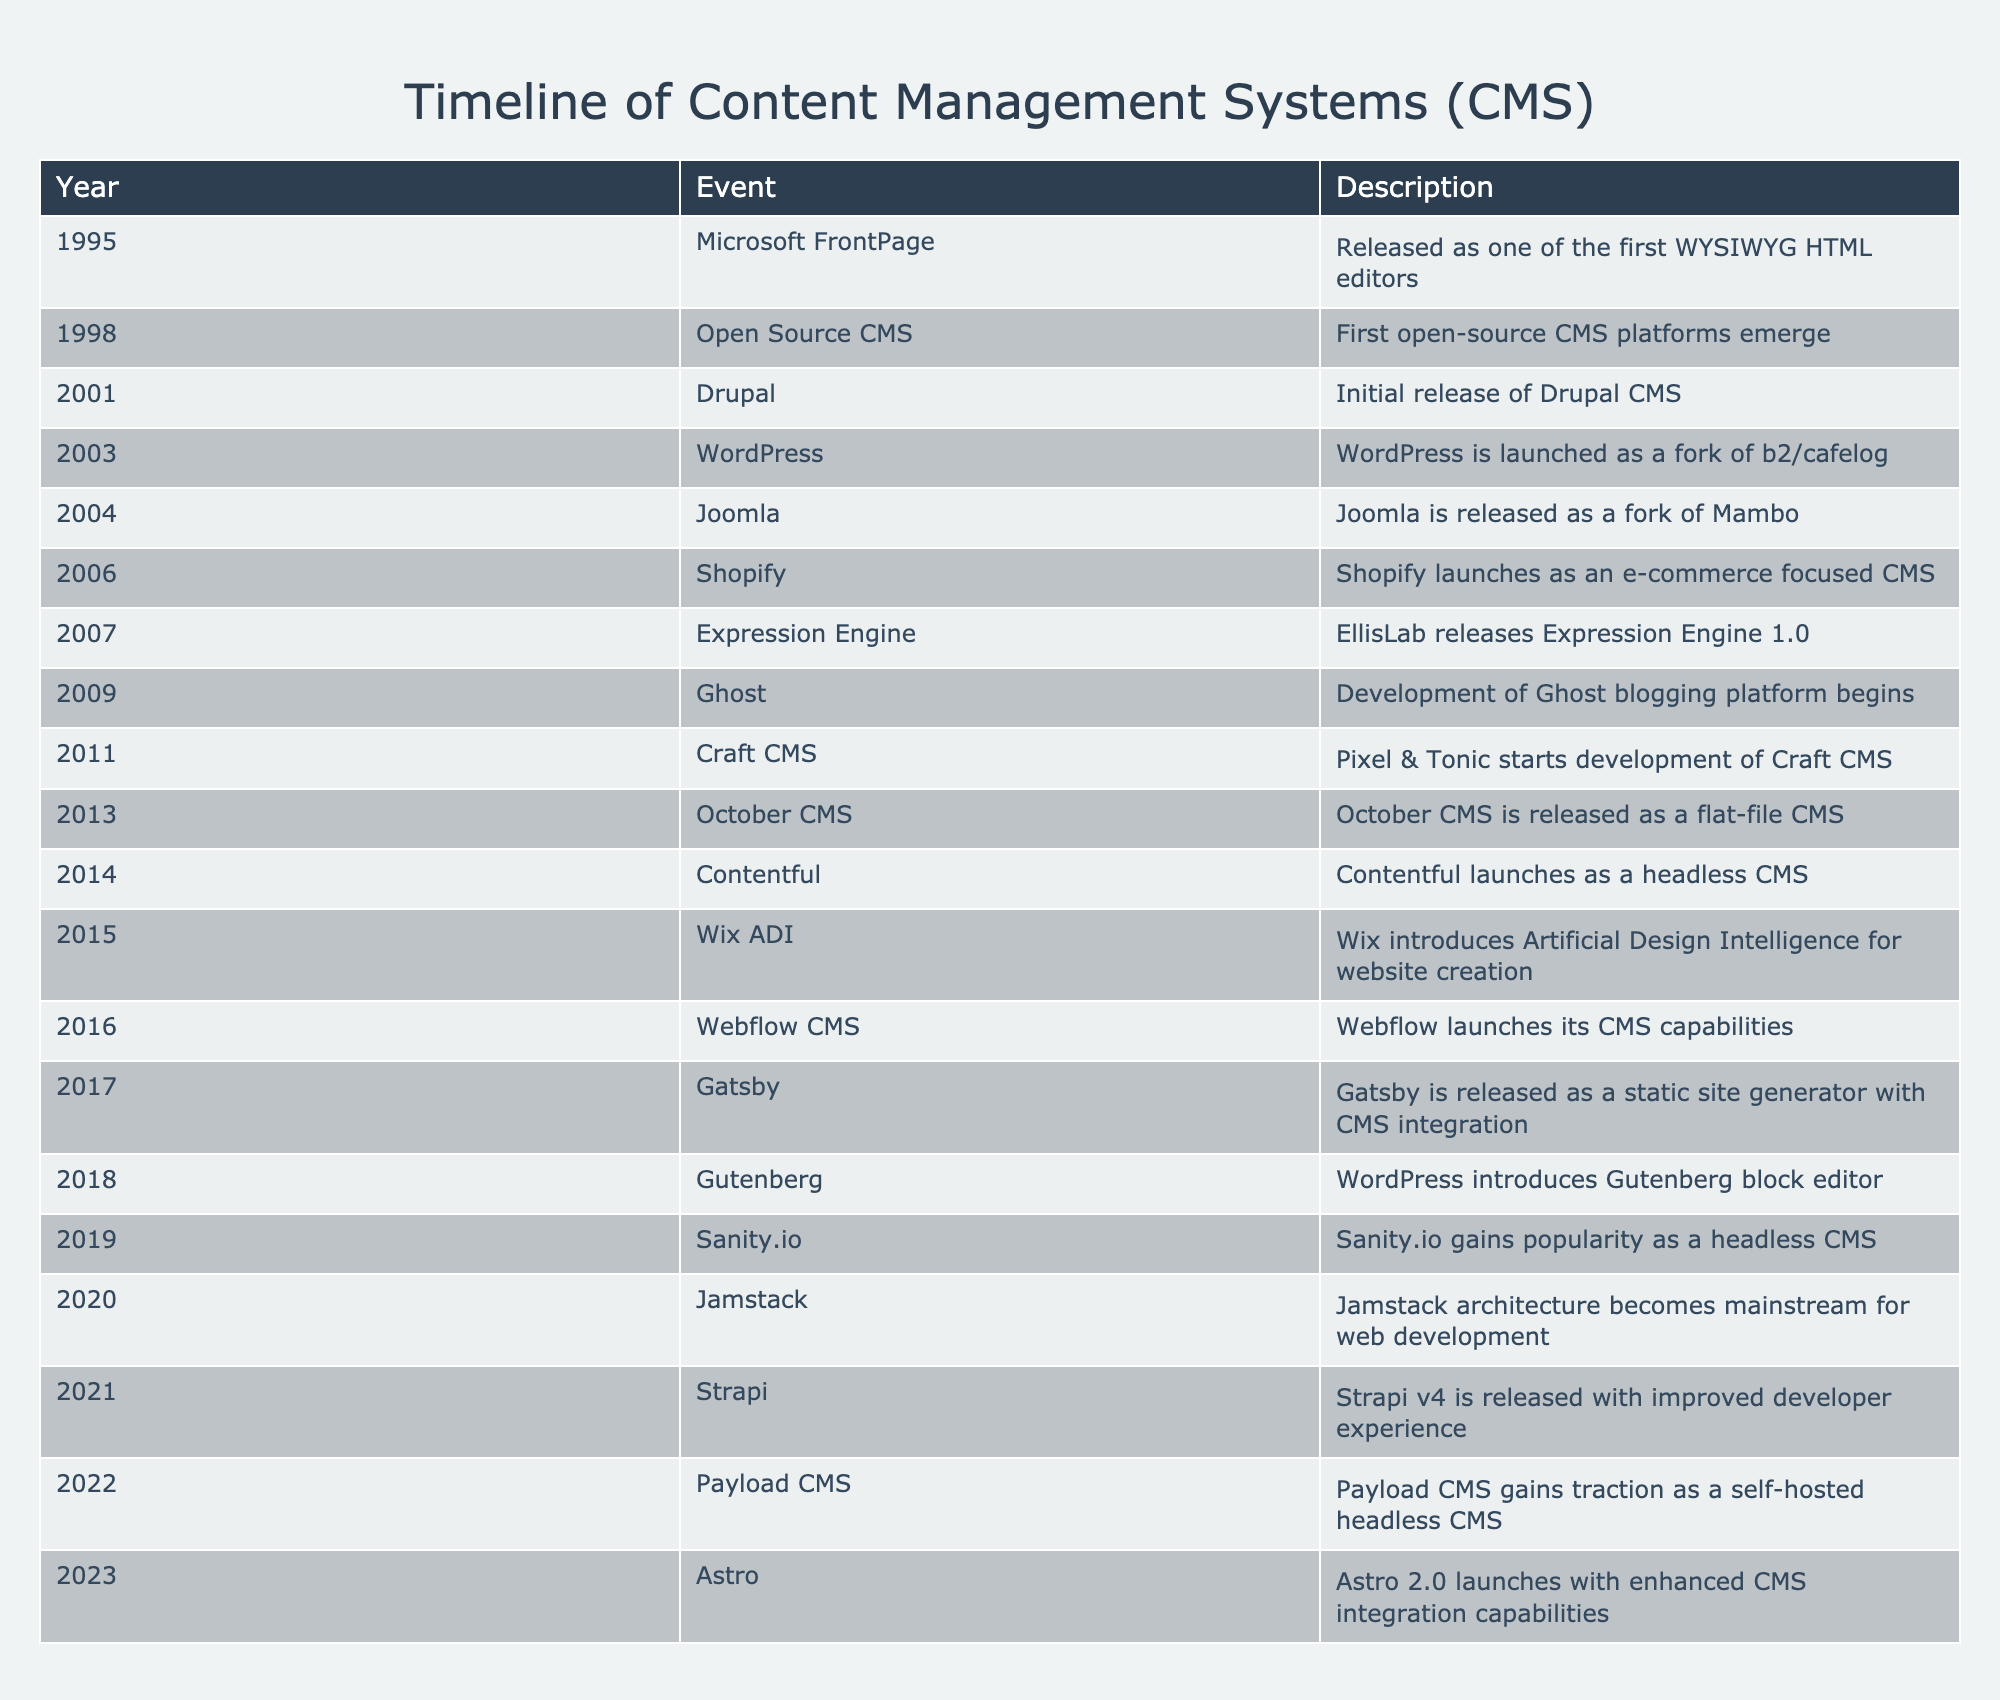What year was WordPress launched? By scanning the timeline table, I can locate the entry for WordPress, which clearly states that it was launched in the year 2003.
Answer: 2003 Which CMS was released first, Joomla or Drupal? By comparing the years of release, I see that Drupal was released in 2001, while Joomla was released in 2004, indicating that Drupal was launched earlier.
Answer: Drupal How many years apart were the launches of Shopify and Expression Engine? Shopify was launched in 2006 and Expression Engine in 2007. Calculating the difference, 2007 - 2006 equals one year; thus, the launches were one year apart.
Answer: 1 year True or False: Ghost was developed before the introduction of the Gutenberg block editor in WordPress. Checking the timeline, I find that Ghost's development began in 2009, while the Gutenberg block editor was introduced in WordPress in 2018. Since 2009 is earlier than 2018, the statement is true.
Answer: True What is the total number of CMS platforms introduced between 2010 and 2020? I can identify the relevant entries: Craft CMS (2011), October CMS (2013), Contentful (2014), Wix ADI (2015), Webflow CMS (2016), Gatsby (2017), Sanity.io (2019), and Jamstack (2020). Counting these, I have a total of 8 CMS platforms launched in that period.
Answer: 8 What trend can be observed regarding the emergence of headless CMS platforms from 2014 to 2023? By looking at the timeline, I can identify that headless CMS platforms like Contentful, Sanity.io, and Payload CMS emerged in 2014, 2019, and 2022, respectively. This indicates a growing trend towards headless CMSs in recent years, as more platforms catered to this model.
Answer: Increasing trend In which two years were major updates/releases of well-known CMS systems made, and what were those updates? The table shows significant updates in years like 2018 with the introduction of the Gutenberg block editor in WordPress and in 2021 with the release of Strapi v4, which offered improved developer experience. By combining this information, I can conclude that those were two notable years for major CMS updates.
Answer: 2018 and 2021 Which CMS was launched as an alternative to Mambo? The entry for Joomla in the table states that it was released as a fork of Mambo, making it an alternative to that earlier CMS.
Answer: Joomla 